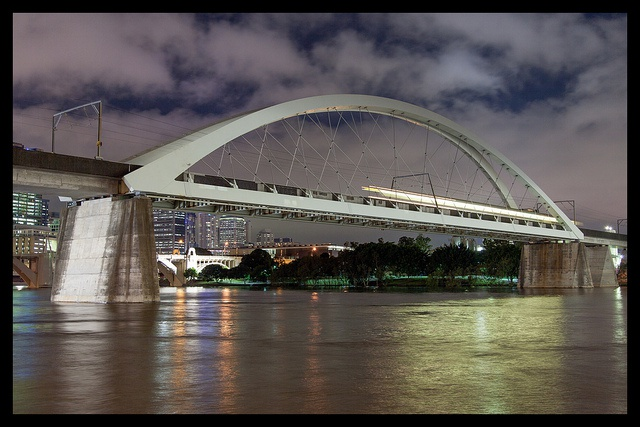Describe the objects in this image and their specific colors. I can see a train in black, ivory, gray, and darkgray tones in this image. 